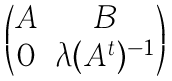Convert formula to latex. <formula><loc_0><loc_0><loc_500><loc_500>\begin{pmatrix} A & B \\ 0 & \lambda ( A ^ { t } ) ^ { - 1 } \\ \end{pmatrix}</formula> 